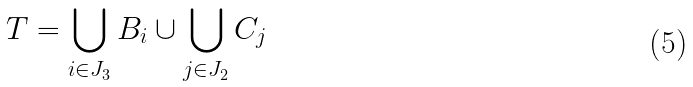<formula> <loc_0><loc_0><loc_500><loc_500>T = \bigcup _ { i \in J _ { 3 } } B _ { i } \cup \bigcup _ { j \in J _ { 2 } } C _ { j }</formula> 